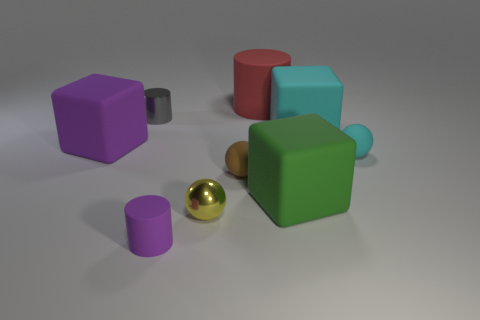How big is the cylinder to the left of the purple rubber object that is in front of the big green block?
Offer a terse response. Small. Is the number of tiny rubber objects that are in front of the tiny cyan rubber object greater than the number of brown spheres that are in front of the cyan rubber cube?
Your answer should be very brief. Yes. How many spheres are either large gray objects or small purple objects?
Make the answer very short. 0. Does the small rubber object on the right side of the big red cylinder have the same shape as the green object?
Ensure brevity in your answer.  No. What is the color of the big cylinder?
Make the answer very short. Red. There is another matte thing that is the same shape as the small brown rubber object; what color is it?
Your answer should be very brief. Cyan. How many other small rubber things are the same shape as the small gray object?
Give a very brief answer. 1. What number of objects are either purple matte cylinders or large rubber things behind the big green cube?
Your answer should be very brief. 4. Is the color of the large matte cylinder the same as the tiny metal object on the left side of the tiny rubber cylinder?
Keep it short and to the point. No. How big is the object that is both behind the large cyan matte object and to the left of the yellow shiny object?
Give a very brief answer. Small. 